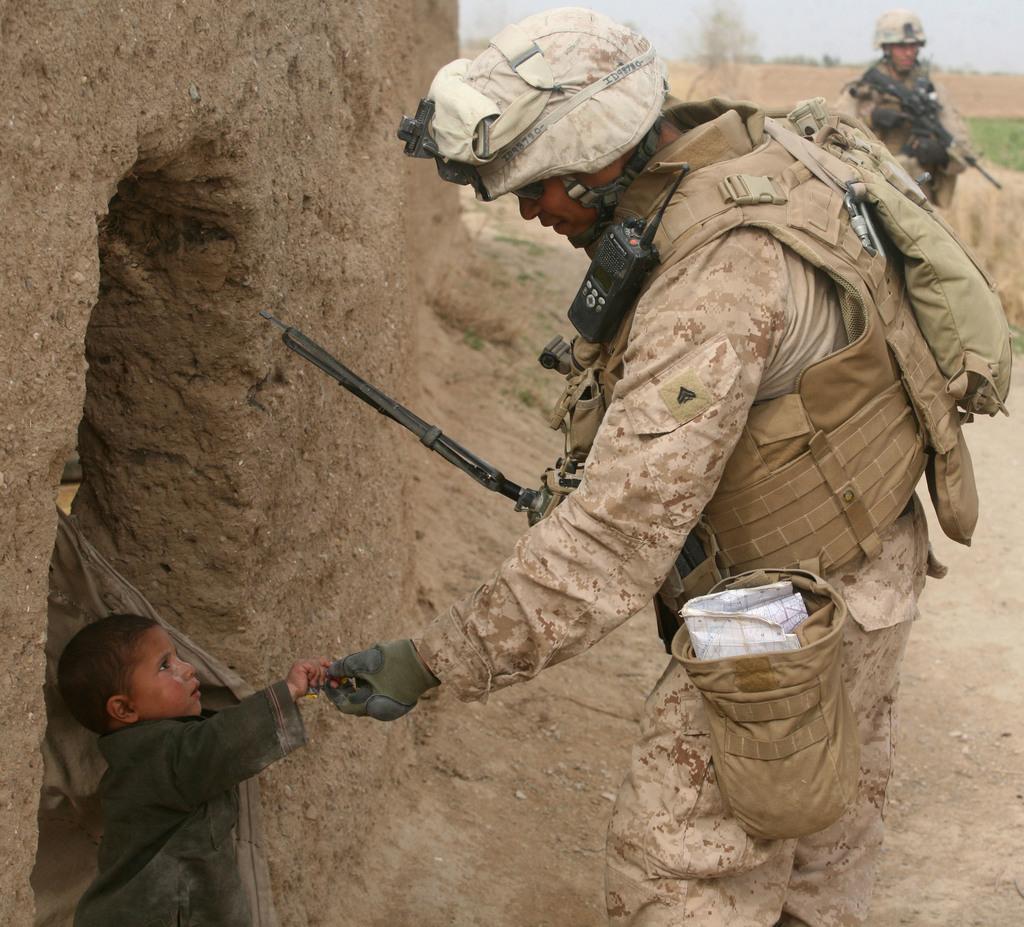Could you give a brief overview of what you see in this image? There is a man standing and wore helmet,bag and glove and we can see gun,in front of this man we can see a boy and we can see wall. In the background there is a man and we can see grass,tree and sky. 